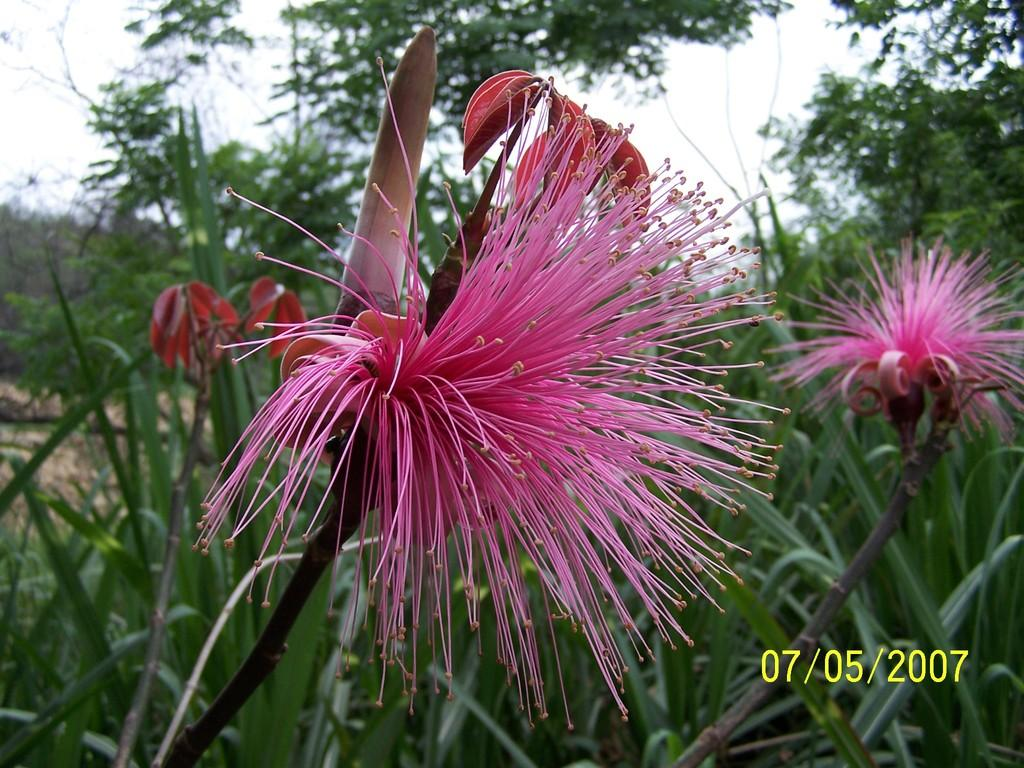What can be seen in the background of the image? There is a sky and trees visible in the background of the image. What types of flora are present in the image? The image contains flowers and plants. Is there any text or information included in the image? Yes, there is a date in the bottom right corner of the image. Can you tell me how many fans are visible in the image? There are no fans present in the image. What type of bomb is depicted in the image? There is no bomb depicted in the image; it contains flowers, plants, and a date. 